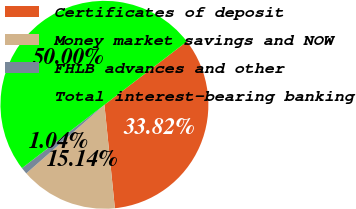Convert chart. <chart><loc_0><loc_0><loc_500><loc_500><pie_chart><fcel>Certificates of deposit<fcel>Money market savings and NOW<fcel>FHLB advances and other<fcel>Total interest-bearing banking<nl><fcel>33.82%<fcel>15.14%<fcel>1.04%<fcel>50.0%<nl></chart> 